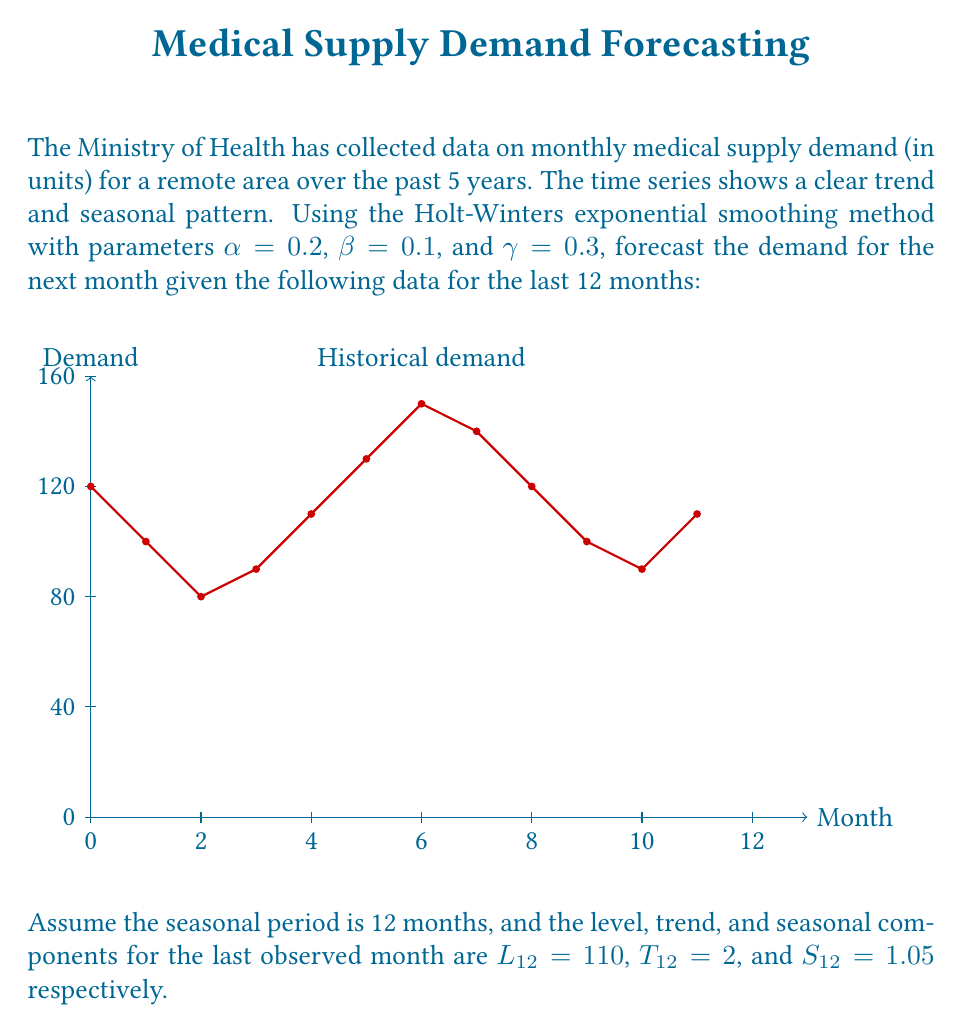Help me with this question. To forecast the demand for the next month using the Holt-Winters method, we need to apply the following steps:

1) Update the level component:
   $$L_{13} = \alpha(Y_{12}/S_{12}) + (1-\alpha)(L_{12} + T_{12})$$
   $$L_{13} = 0.2(110/1.05) + 0.8(110 + 2) = 110.95$$

2) Update the trend component:
   $$T_{13} = \beta(L_{13} - L_{12}) + (1-\beta)T_{12}$$
   $$T_{13} = 0.1(110.95 - 110) + 0.9(2) = 1.895$$

3) Update the seasonal component:
   $$S_{1} = \gamma(Y_{12}/L_{13}) + (1-\gamma)S_{1}$$
   $$S_{1} = 0.3(110/110.95) + 0.7(1.05) = 1.0365$$

4) Calculate the forecast for the next month:
   $$F_{13} = (L_{13} + T_{13}) * S_{1}$$
   $$F_{13} = (110.95 + 1.895) * 1.0365 = 116.85$$

Therefore, the forecasted demand for the next month is approximately 116.85 units.
Answer: 116.85 units 